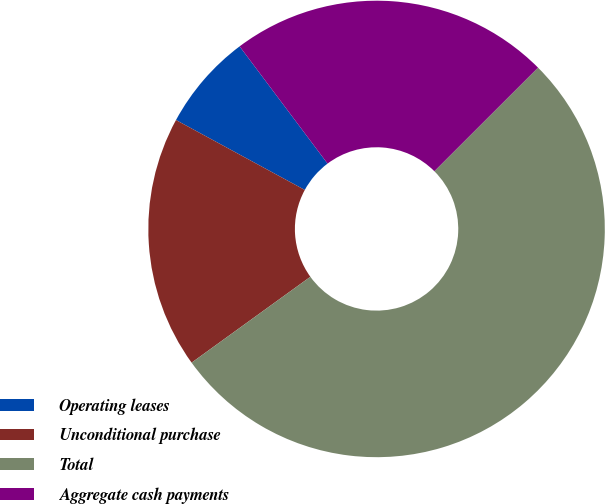<chart> <loc_0><loc_0><loc_500><loc_500><pie_chart><fcel>Operating leases<fcel>Unconditional purchase<fcel>Total<fcel>Aggregate cash payments<nl><fcel>6.84%<fcel>17.88%<fcel>52.53%<fcel>22.75%<nl></chart> 